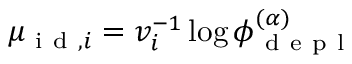Convert formula to latex. <formula><loc_0><loc_0><loc_500><loc_500>\mu _ { i d , i } = v _ { i } ^ { - 1 } \log \phi _ { d e p l } ^ { ( \alpha ) }</formula> 